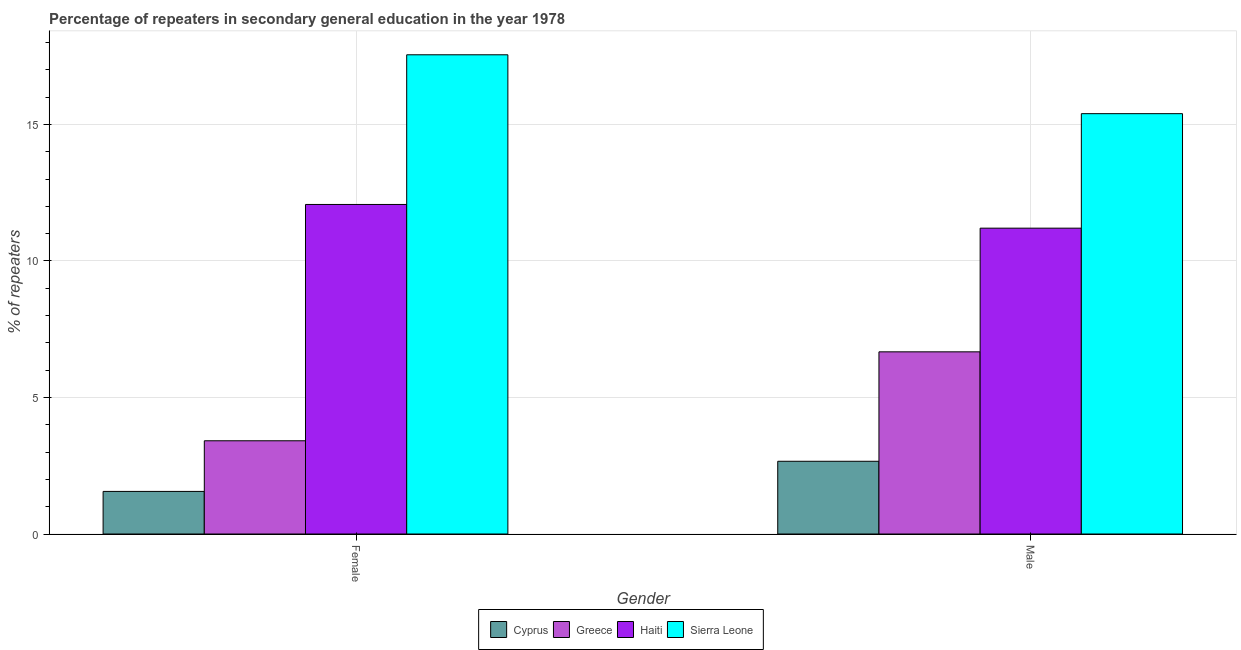How many different coloured bars are there?
Ensure brevity in your answer.  4. How many groups of bars are there?
Keep it short and to the point. 2. How many bars are there on the 1st tick from the right?
Provide a short and direct response. 4. What is the label of the 1st group of bars from the left?
Offer a terse response. Female. What is the percentage of male repeaters in Haiti?
Provide a short and direct response. 11.2. Across all countries, what is the maximum percentage of male repeaters?
Provide a short and direct response. 15.4. Across all countries, what is the minimum percentage of male repeaters?
Make the answer very short. 2.66. In which country was the percentage of male repeaters maximum?
Your answer should be very brief. Sierra Leone. In which country was the percentage of female repeaters minimum?
Offer a terse response. Cyprus. What is the total percentage of female repeaters in the graph?
Your answer should be very brief. 34.6. What is the difference between the percentage of male repeaters in Cyprus and that in Haiti?
Your response must be concise. -8.54. What is the difference between the percentage of male repeaters in Sierra Leone and the percentage of female repeaters in Greece?
Your response must be concise. 11.98. What is the average percentage of male repeaters per country?
Provide a succinct answer. 8.98. What is the difference between the percentage of female repeaters and percentage of male repeaters in Sierra Leone?
Provide a succinct answer. 2.16. What is the ratio of the percentage of male repeaters in Cyprus to that in Greece?
Offer a terse response. 0.4. In how many countries, is the percentage of female repeaters greater than the average percentage of female repeaters taken over all countries?
Your answer should be compact. 2. What does the 4th bar from the left in Female represents?
Make the answer very short. Sierra Leone. What is the difference between two consecutive major ticks on the Y-axis?
Keep it short and to the point. 5. Does the graph contain any zero values?
Offer a terse response. No. Does the graph contain grids?
Offer a terse response. Yes. How many legend labels are there?
Give a very brief answer. 4. What is the title of the graph?
Provide a succinct answer. Percentage of repeaters in secondary general education in the year 1978. What is the label or title of the X-axis?
Make the answer very short. Gender. What is the label or title of the Y-axis?
Offer a terse response. % of repeaters. What is the % of repeaters in Cyprus in Female?
Ensure brevity in your answer.  1.56. What is the % of repeaters of Greece in Female?
Your response must be concise. 3.42. What is the % of repeaters of Haiti in Female?
Provide a succinct answer. 12.07. What is the % of repeaters in Sierra Leone in Female?
Make the answer very short. 17.55. What is the % of repeaters of Cyprus in Male?
Your answer should be compact. 2.66. What is the % of repeaters in Greece in Male?
Your answer should be compact. 6.67. What is the % of repeaters of Haiti in Male?
Give a very brief answer. 11.2. What is the % of repeaters in Sierra Leone in Male?
Keep it short and to the point. 15.4. Across all Gender, what is the maximum % of repeaters of Cyprus?
Make the answer very short. 2.66. Across all Gender, what is the maximum % of repeaters in Greece?
Provide a succinct answer. 6.67. Across all Gender, what is the maximum % of repeaters in Haiti?
Your response must be concise. 12.07. Across all Gender, what is the maximum % of repeaters of Sierra Leone?
Ensure brevity in your answer.  17.55. Across all Gender, what is the minimum % of repeaters of Cyprus?
Your answer should be very brief. 1.56. Across all Gender, what is the minimum % of repeaters in Greece?
Your answer should be very brief. 3.42. Across all Gender, what is the minimum % of repeaters of Haiti?
Offer a very short reply. 11.2. Across all Gender, what is the minimum % of repeaters in Sierra Leone?
Ensure brevity in your answer.  15.4. What is the total % of repeaters in Cyprus in the graph?
Provide a succinct answer. 4.22. What is the total % of repeaters in Greece in the graph?
Give a very brief answer. 10.09. What is the total % of repeaters of Haiti in the graph?
Offer a very short reply. 23.27. What is the total % of repeaters in Sierra Leone in the graph?
Offer a terse response. 32.95. What is the difference between the % of repeaters of Cyprus in Female and that in Male?
Your answer should be very brief. -1.1. What is the difference between the % of repeaters of Greece in Female and that in Male?
Your answer should be compact. -3.26. What is the difference between the % of repeaters of Haiti in Female and that in Male?
Offer a terse response. 0.87. What is the difference between the % of repeaters of Sierra Leone in Female and that in Male?
Your answer should be very brief. 2.16. What is the difference between the % of repeaters in Cyprus in Female and the % of repeaters in Greece in Male?
Your answer should be very brief. -5.11. What is the difference between the % of repeaters in Cyprus in Female and the % of repeaters in Haiti in Male?
Your answer should be compact. -9.64. What is the difference between the % of repeaters of Cyprus in Female and the % of repeaters of Sierra Leone in Male?
Offer a terse response. -13.84. What is the difference between the % of repeaters in Greece in Female and the % of repeaters in Haiti in Male?
Keep it short and to the point. -7.79. What is the difference between the % of repeaters in Greece in Female and the % of repeaters in Sierra Leone in Male?
Ensure brevity in your answer.  -11.98. What is the difference between the % of repeaters in Haiti in Female and the % of repeaters in Sierra Leone in Male?
Offer a very short reply. -3.33. What is the average % of repeaters of Cyprus per Gender?
Keep it short and to the point. 2.11. What is the average % of repeaters in Greece per Gender?
Your answer should be very brief. 5.04. What is the average % of repeaters of Haiti per Gender?
Give a very brief answer. 11.64. What is the average % of repeaters of Sierra Leone per Gender?
Offer a very short reply. 16.47. What is the difference between the % of repeaters of Cyprus and % of repeaters of Greece in Female?
Provide a short and direct response. -1.85. What is the difference between the % of repeaters in Cyprus and % of repeaters in Haiti in Female?
Your answer should be very brief. -10.51. What is the difference between the % of repeaters in Cyprus and % of repeaters in Sierra Leone in Female?
Keep it short and to the point. -15.99. What is the difference between the % of repeaters of Greece and % of repeaters of Haiti in Female?
Provide a succinct answer. -8.66. What is the difference between the % of repeaters in Greece and % of repeaters in Sierra Leone in Female?
Provide a succinct answer. -14.14. What is the difference between the % of repeaters in Haiti and % of repeaters in Sierra Leone in Female?
Make the answer very short. -5.48. What is the difference between the % of repeaters of Cyprus and % of repeaters of Greece in Male?
Your answer should be very brief. -4.01. What is the difference between the % of repeaters of Cyprus and % of repeaters of Haiti in Male?
Give a very brief answer. -8.54. What is the difference between the % of repeaters in Cyprus and % of repeaters in Sierra Leone in Male?
Offer a terse response. -12.73. What is the difference between the % of repeaters in Greece and % of repeaters in Haiti in Male?
Your answer should be very brief. -4.53. What is the difference between the % of repeaters of Greece and % of repeaters of Sierra Leone in Male?
Your response must be concise. -8.72. What is the difference between the % of repeaters in Haiti and % of repeaters in Sierra Leone in Male?
Your answer should be very brief. -4.19. What is the ratio of the % of repeaters in Cyprus in Female to that in Male?
Your answer should be very brief. 0.59. What is the ratio of the % of repeaters of Greece in Female to that in Male?
Keep it short and to the point. 0.51. What is the ratio of the % of repeaters of Haiti in Female to that in Male?
Your answer should be very brief. 1.08. What is the ratio of the % of repeaters in Sierra Leone in Female to that in Male?
Provide a short and direct response. 1.14. What is the difference between the highest and the second highest % of repeaters of Cyprus?
Your response must be concise. 1.1. What is the difference between the highest and the second highest % of repeaters in Greece?
Your answer should be compact. 3.26. What is the difference between the highest and the second highest % of repeaters of Haiti?
Your answer should be compact. 0.87. What is the difference between the highest and the second highest % of repeaters in Sierra Leone?
Provide a short and direct response. 2.16. What is the difference between the highest and the lowest % of repeaters in Cyprus?
Ensure brevity in your answer.  1.1. What is the difference between the highest and the lowest % of repeaters in Greece?
Provide a succinct answer. 3.26. What is the difference between the highest and the lowest % of repeaters in Haiti?
Ensure brevity in your answer.  0.87. What is the difference between the highest and the lowest % of repeaters in Sierra Leone?
Your answer should be very brief. 2.16. 